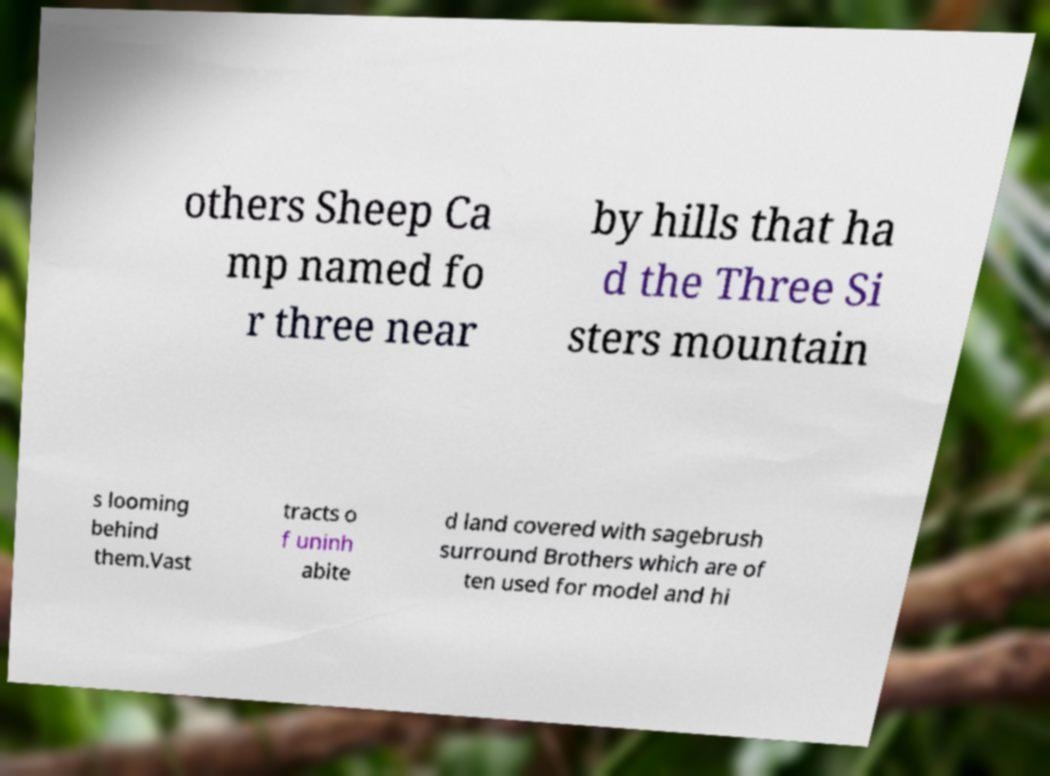Could you assist in decoding the text presented in this image and type it out clearly? others Sheep Ca mp named fo r three near by hills that ha d the Three Si sters mountain s looming behind them.Vast tracts o f uninh abite d land covered with sagebrush surround Brothers which are of ten used for model and hi 